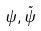Convert formula to latex. <formula><loc_0><loc_0><loc_500><loc_500>\psi , \tilde { \psi }</formula> 